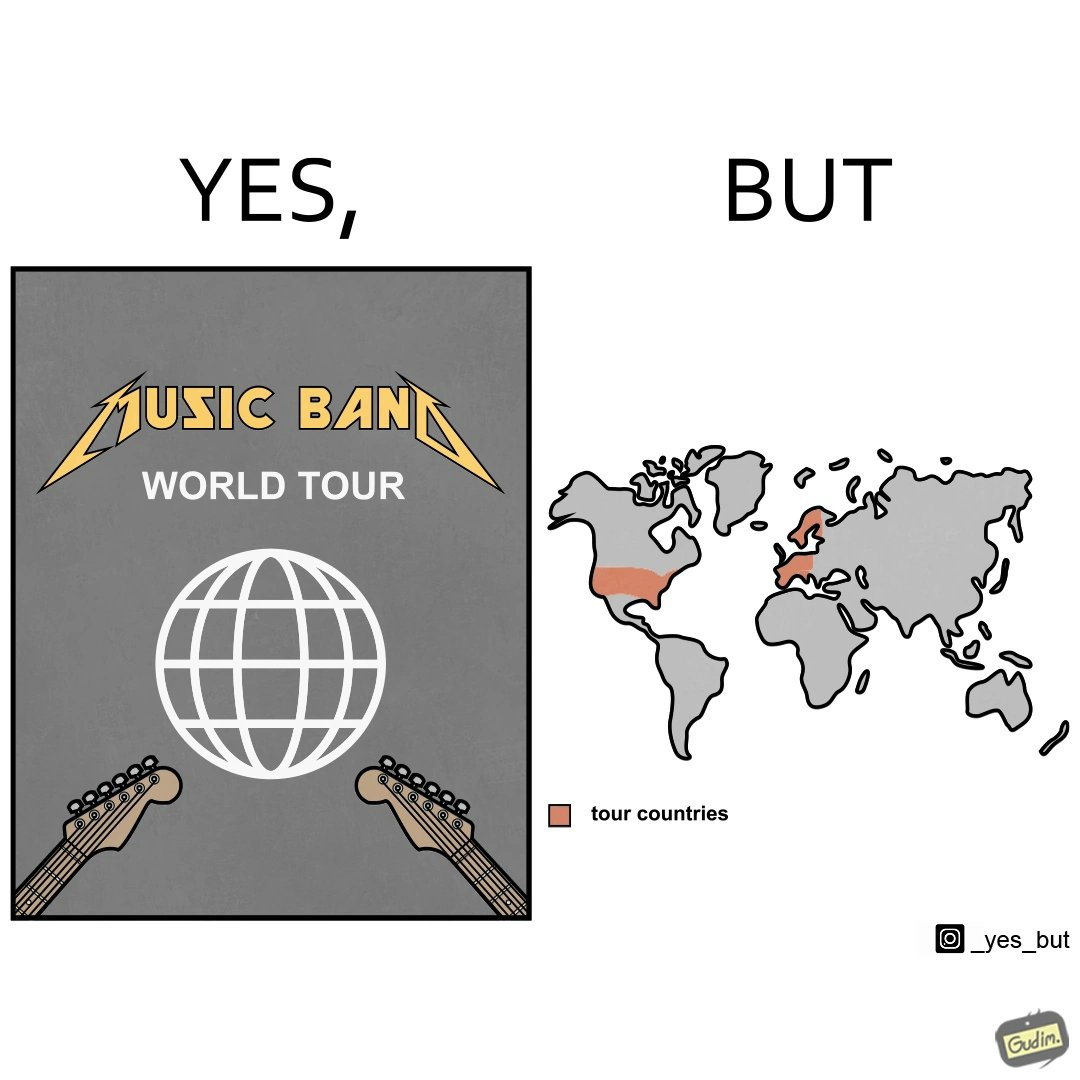What is shown in the left half versus the right half of this image? In the left part of the image: a poster of some music band's world tour In the right part of the image: a world map highlighting some parts as tour countries 